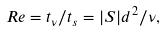Convert formula to latex. <formula><loc_0><loc_0><loc_500><loc_500>R e = t _ { \nu } / t _ { s } = | S | d ^ { 2 } / \nu ,</formula> 